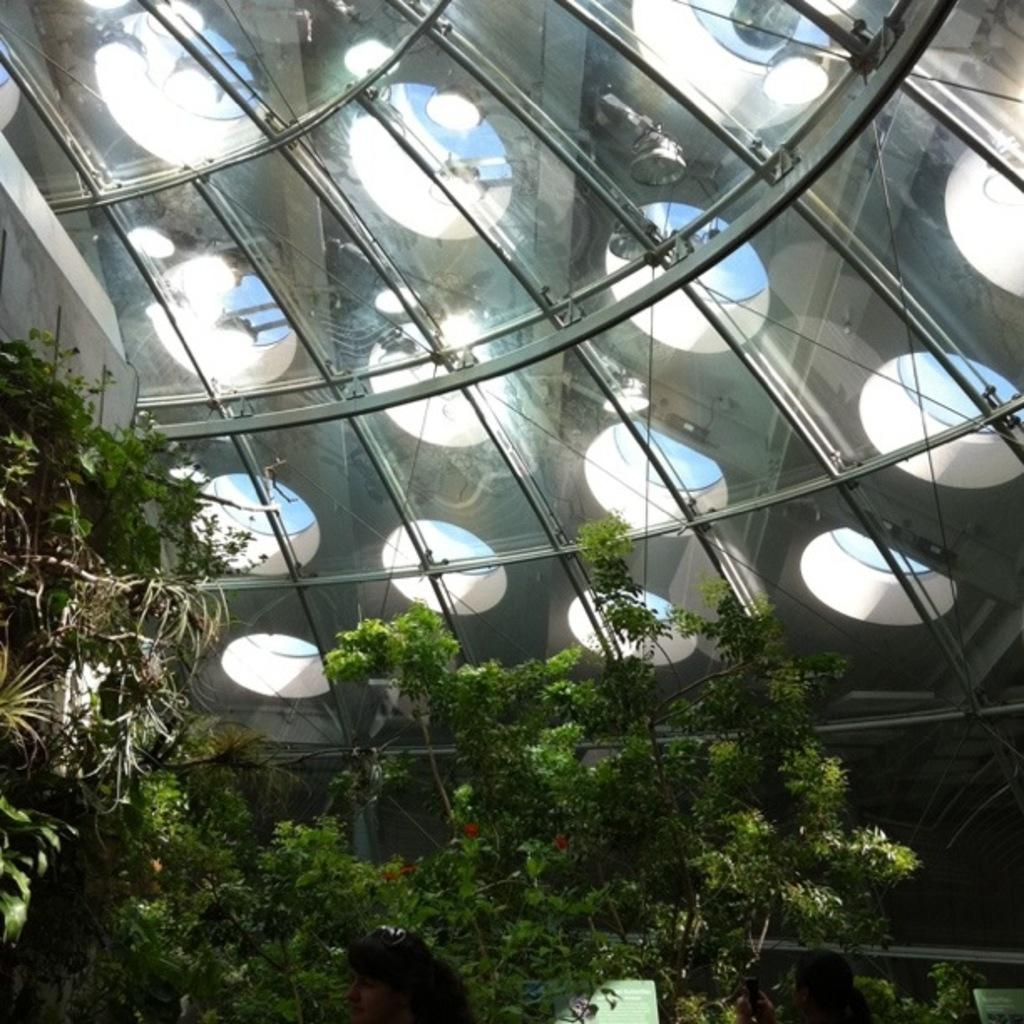What type of natural elements can be seen in the image? There are trees in the image. What man-made objects are present in the image? There are boards in the image. Are there any human subjects in the image? Yes, there are people in the image. What structure is partially visible in the image? There is a roof visible at the top of the image. What can be used for illumination in the image? There are lights visible in the image. What type of beef is being grilled in the image? There is no beef or grilling activity present in the image. How does the hose contribute to the scene in the image? There is no hose present in the image. 